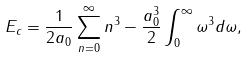<formula> <loc_0><loc_0><loc_500><loc_500>E _ { c } = \frac { 1 } { 2 a _ { 0 } } \sum _ { n = 0 } ^ { \infty } n ^ { 3 } - \frac { a ^ { 3 } _ { 0 } } { 2 } \int _ { 0 } ^ { \infty } \omega ^ { 3 } d \omega ,</formula> 